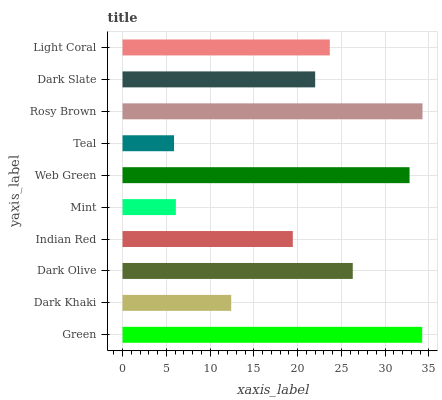Is Teal the minimum?
Answer yes or no. Yes. Is Rosy Brown the maximum?
Answer yes or no. Yes. Is Dark Khaki the minimum?
Answer yes or no. No. Is Dark Khaki the maximum?
Answer yes or no. No. Is Green greater than Dark Khaki?
Answer yes or no. Yes. Is Dark Khaki less than Green?
Answer yes or no. Yes. Is Dark Khaki greater than Green?
Answer yes or no. No. Is Green less than Dark Khaki?
Answer yes or no. No. Is Light Coral the high median?
Answer yes or no. Yes. Is Dark Slate the low median?
Answer yes or no. Yes. Is Mint the high median?
Answer yes or no. No. Is Mint the low median?
Answer yes or no. No. 